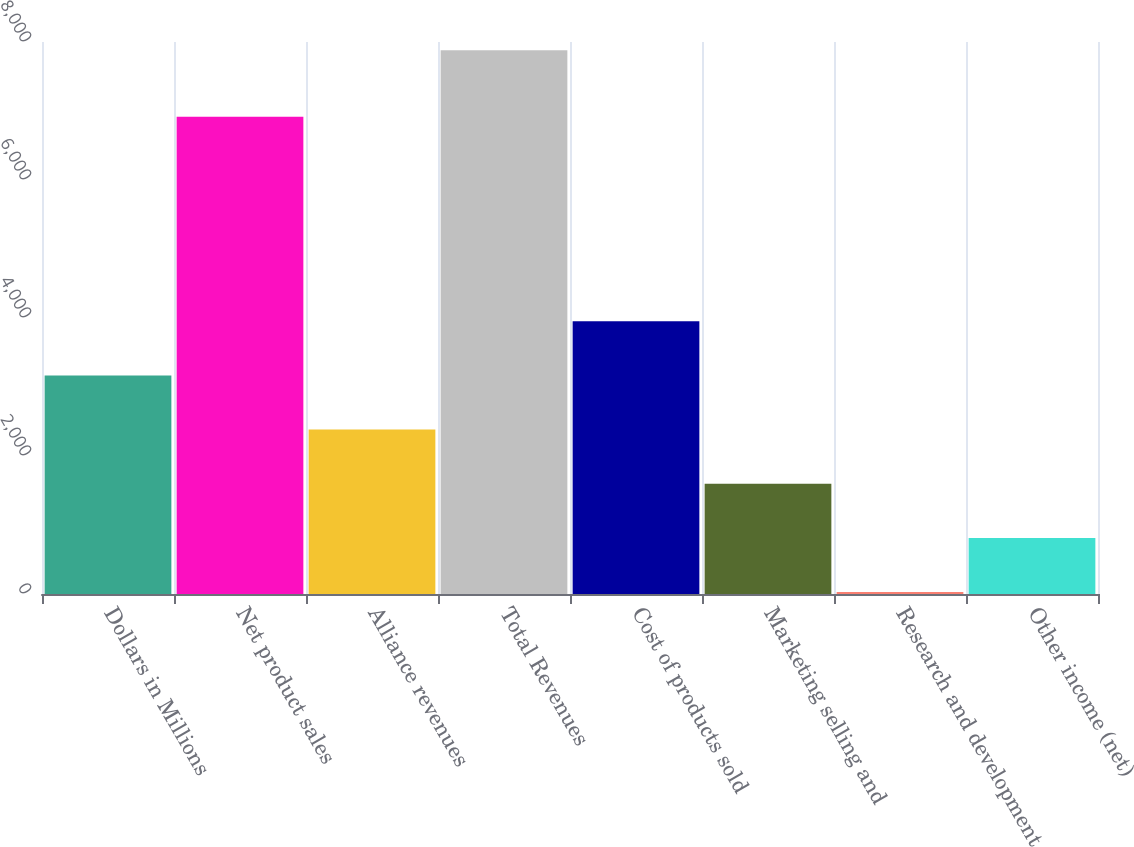<chart> <loc_0><loc_0><loc_500><loc_500><bar_chart><fcel>Dollars in Millions<fcel>Net product sales<fcel>Alliance revenues<fcel>Total Revenues<fcel>Cost of products sold<fcel>Marketing selling and<fcel>Research and development<fcel>Other income (net)<nl><fcel>3168.4<fcel>6917<fcel>2383.3<fcel>7879<fcel>3953.5<fcel>1598.2<fcel>28<fcel>813.1<nl></chart> 